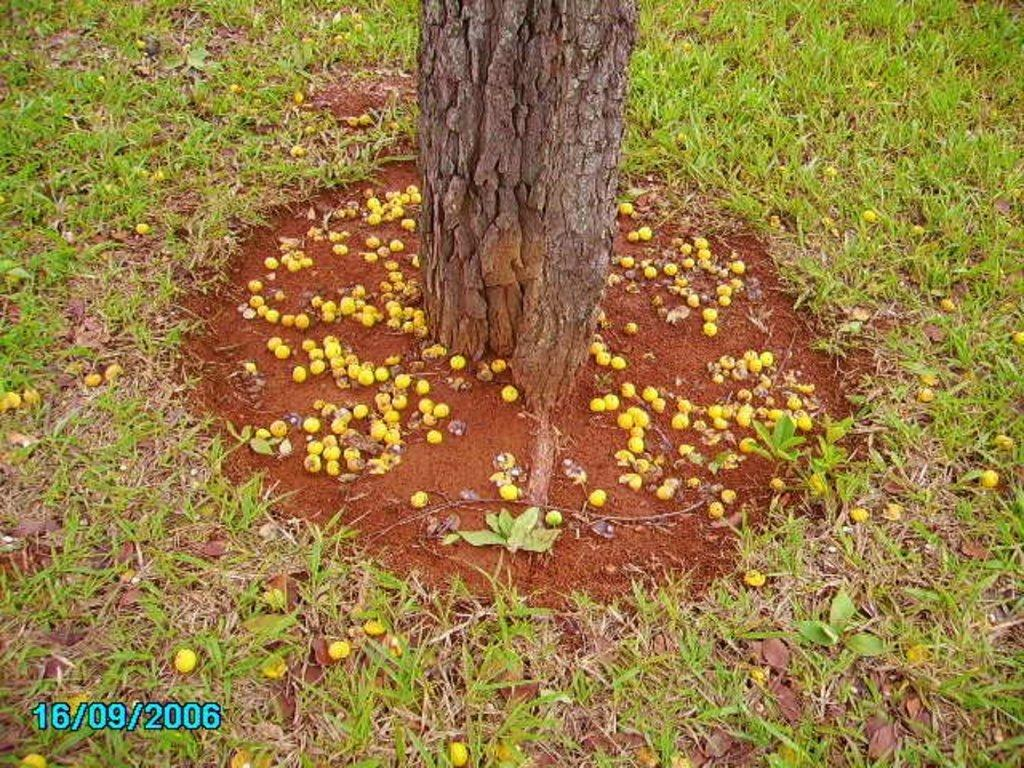What is the main object in the image? There is a tree trunk in the image. What type of vegetation is present on the ground? There is grass on the ground in the image. What can be seen hanging from the tree trunk? There are fruits visible in the image. Is there any text or marking in the image? Yes, there is a watermark in the left bottom corner of the image. What type of blade is being used by the stranger in the image? There is no stranger present in the image, and therefore no blade being used. 